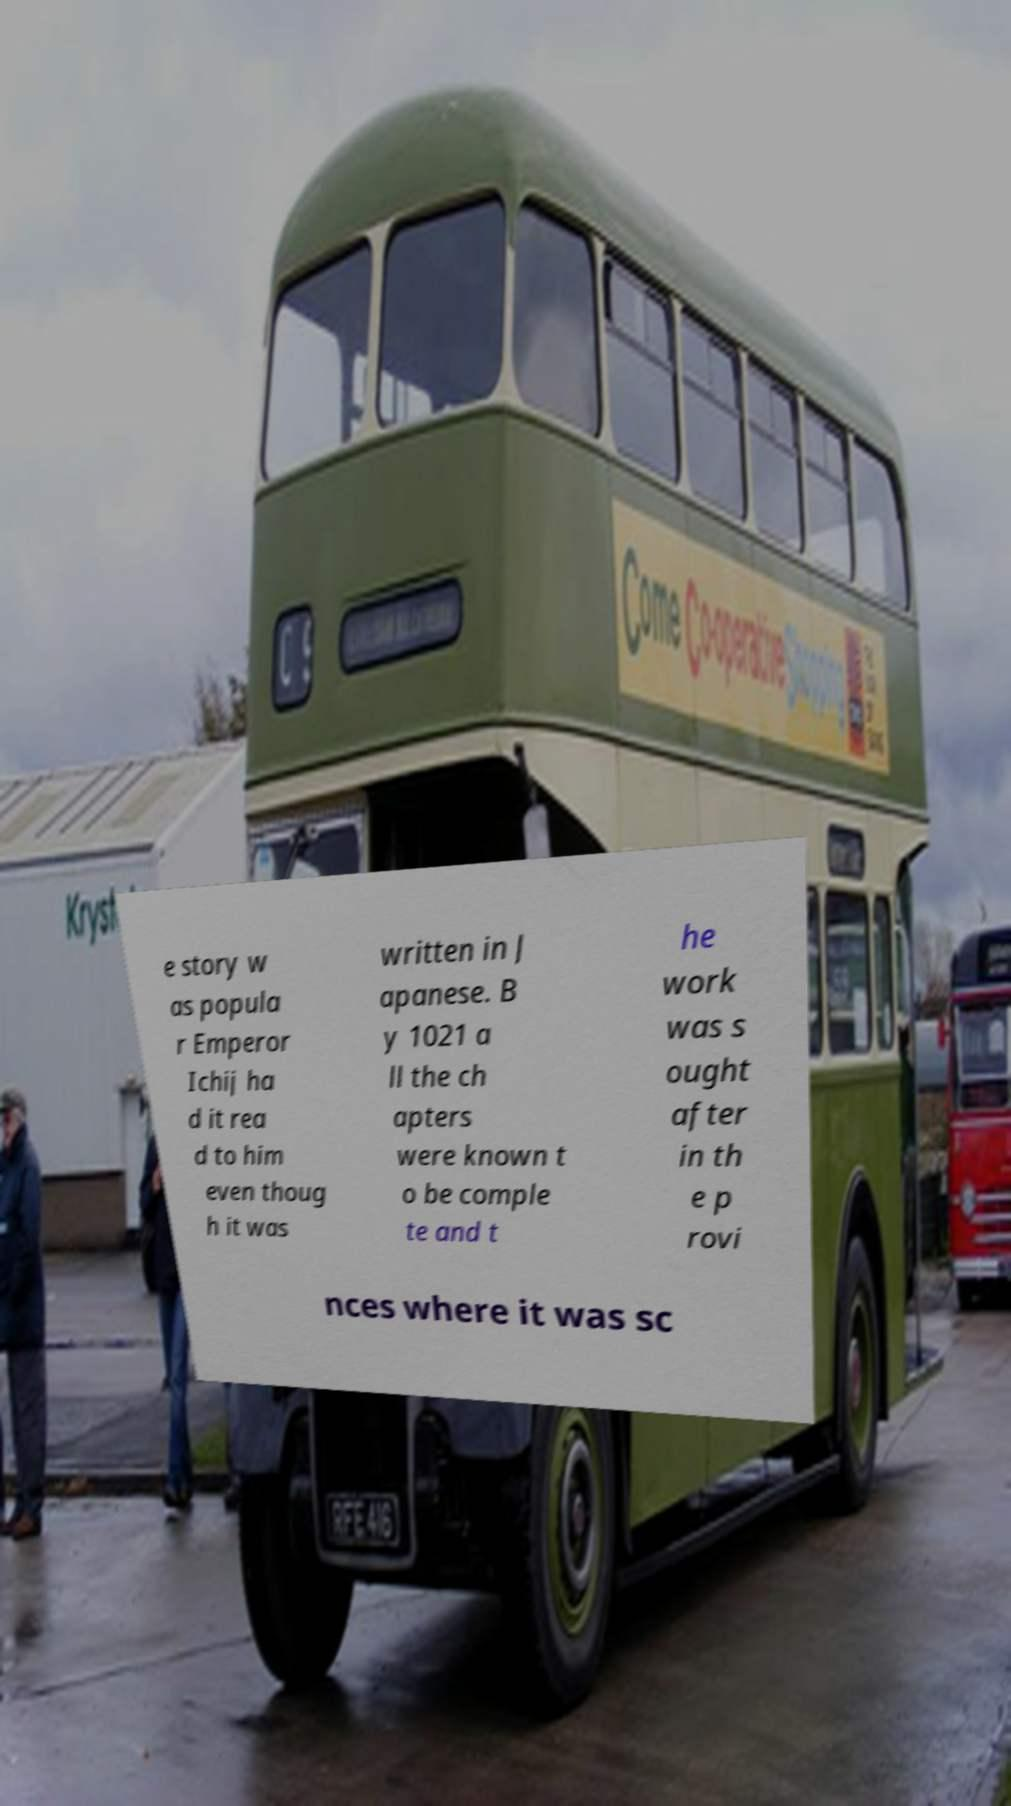What messages or text are displayed in this image? I need them in a readable, typed format. e story w as popula r Emperor Ichij ha d it rea d to him even thoug h it was written in J apanese. B y 1021 a ll the ch apters were known t o be comple te and t he work was s ought after in th e p rovi nces where it was sc 